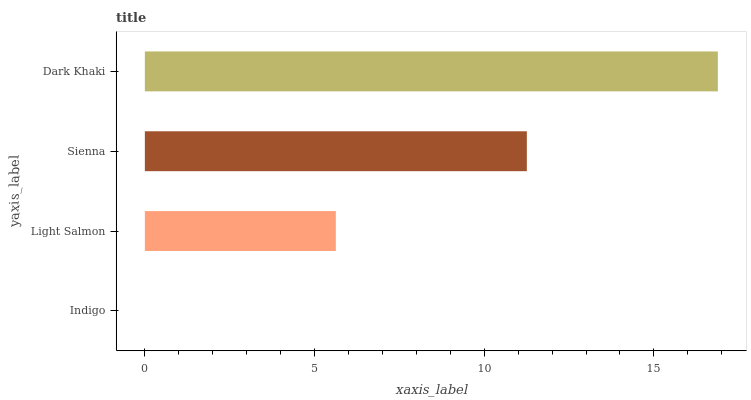Is Indigo the minimum?
Answer yes or no. Yes. Is Dark Khaki the maximum?
Answer yes or no. Yes. Is Light Salmon the minimum?
Answer yes or no. No. Is Light Salmon the maximum?
Answer yes or no. No. Is Light Salmon greater than Indigo?
Answer yes or no. Yes. Is Indigo less than Light Salmon?
Answer yes or no. Yes. Is Indigo greater than Light Salmon?
Answer yes or no. No. Is Light Salmon less than Indigo?
Answer yes or no. No. Is Sienna the high median?
Answer yes or no. Yes. Is Light Salmon the low median?
Answer yes or no. Yes. Is Dark Khaki the high median?
Answer yes or no. No. Is Sienna the low median?
Answer yes or no. No. 